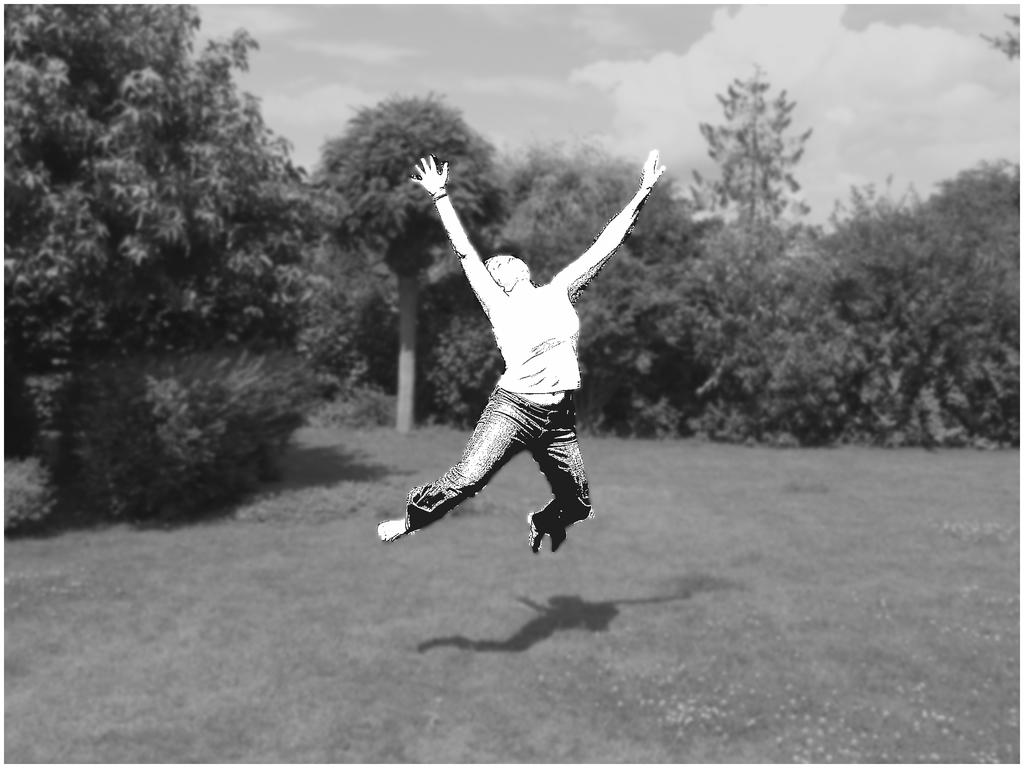What is the color scheme of the image? The image is black and white. What is the person in the image doing? There is a person in the air in the image. What can be seen in the background of the image? There are trees, grass, and clouds visible in the background of the image. What type of government is depicted in the image? There is no government depicted in the image; it features a person in the air and a background with trees, grass, and clouds. What is the person in the image using to play with the ball? There is no ball present in the image. 